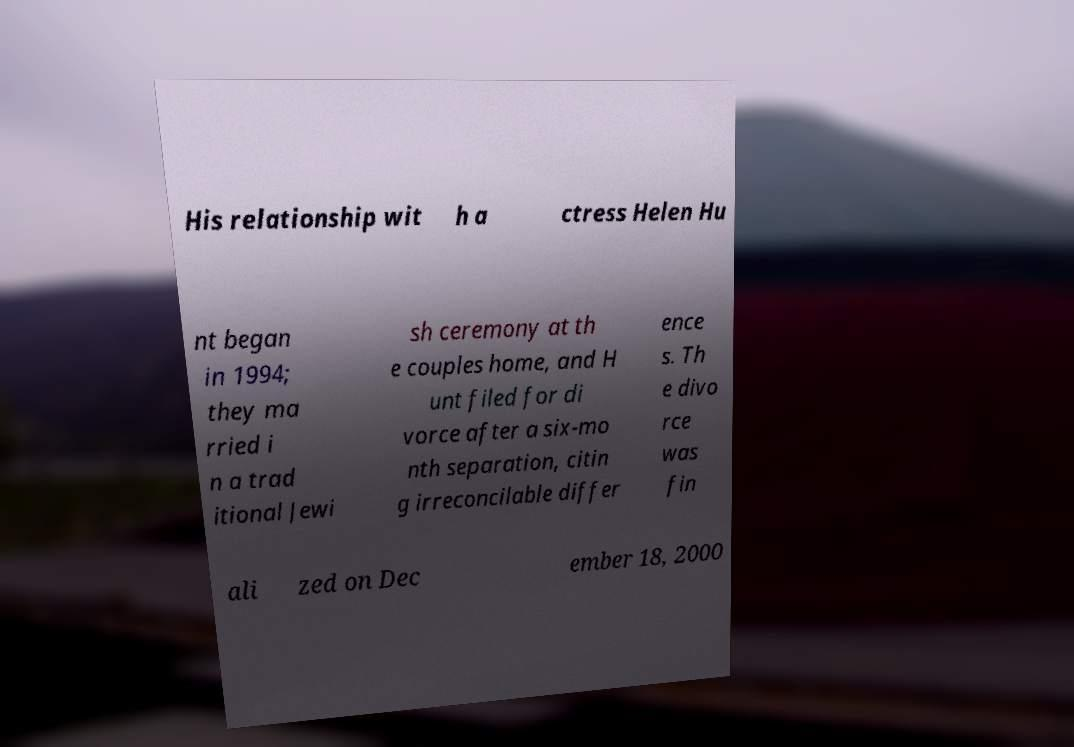What messages or text are displayed in this image? I need them in a readable, typed format. His relationship wit h a ctress Helen Hu nt began in 1994; they ma rried i n a trad itional Jewi sh ceremony at th e couples home, and H unt filed for di vorce after a six-mo nth separation, citin g irreconcilable differ ence s. Th e divo rce was fin ali zed on Dec ember 18, 2000 